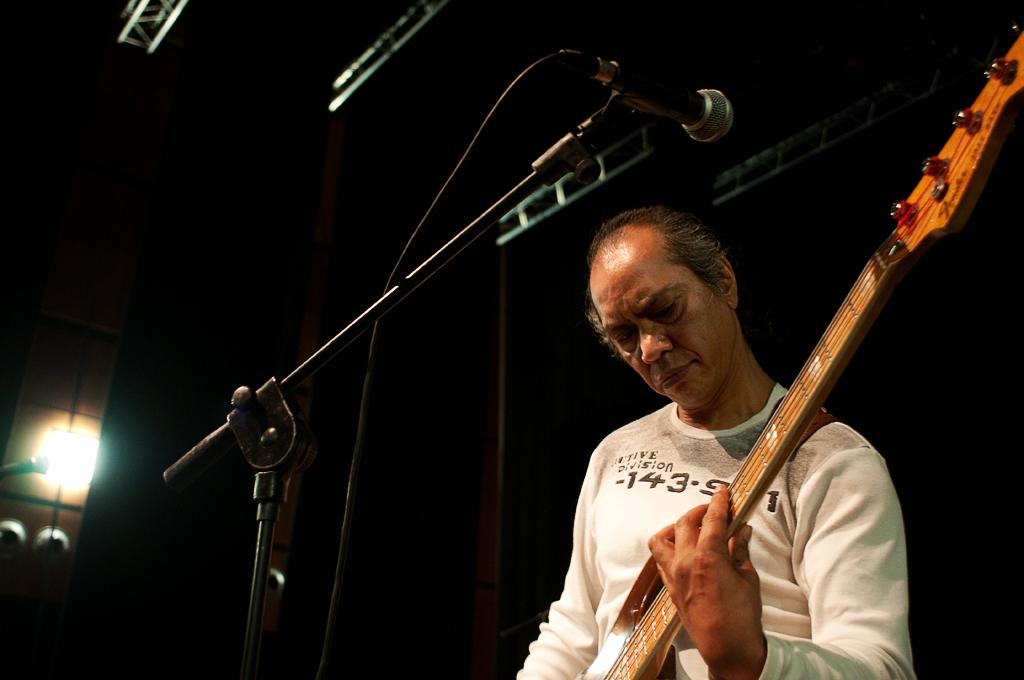Who is the main subject in the image? There is a man in the image. What is the man wearing? The man is wearing a white t-shirt. What is the man doing in the image? The man is playing a guitar. What object is present near the man? There is a microphone stand in the image. How would you describe the lighting in the image? The background of the image is dark. What type of cake is being served in the image? There is no cake present in the image; it features a man playing a guitar with a microphone stand nearby. 